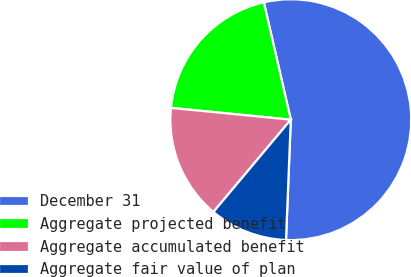Convert chart to OTSL. <chart><loc_0><loc_0><loc_500><loc_500><pie_chart><fcel>December 31<fcel>Aggregate projected benefit<fcel>Aggregate accumulated benefit<fcel>Aggregate fair value of plan<nl><fcel>54.23%<fcel>19.84%<fcel>15.46%<fcel>10.47%<nl></chart> 